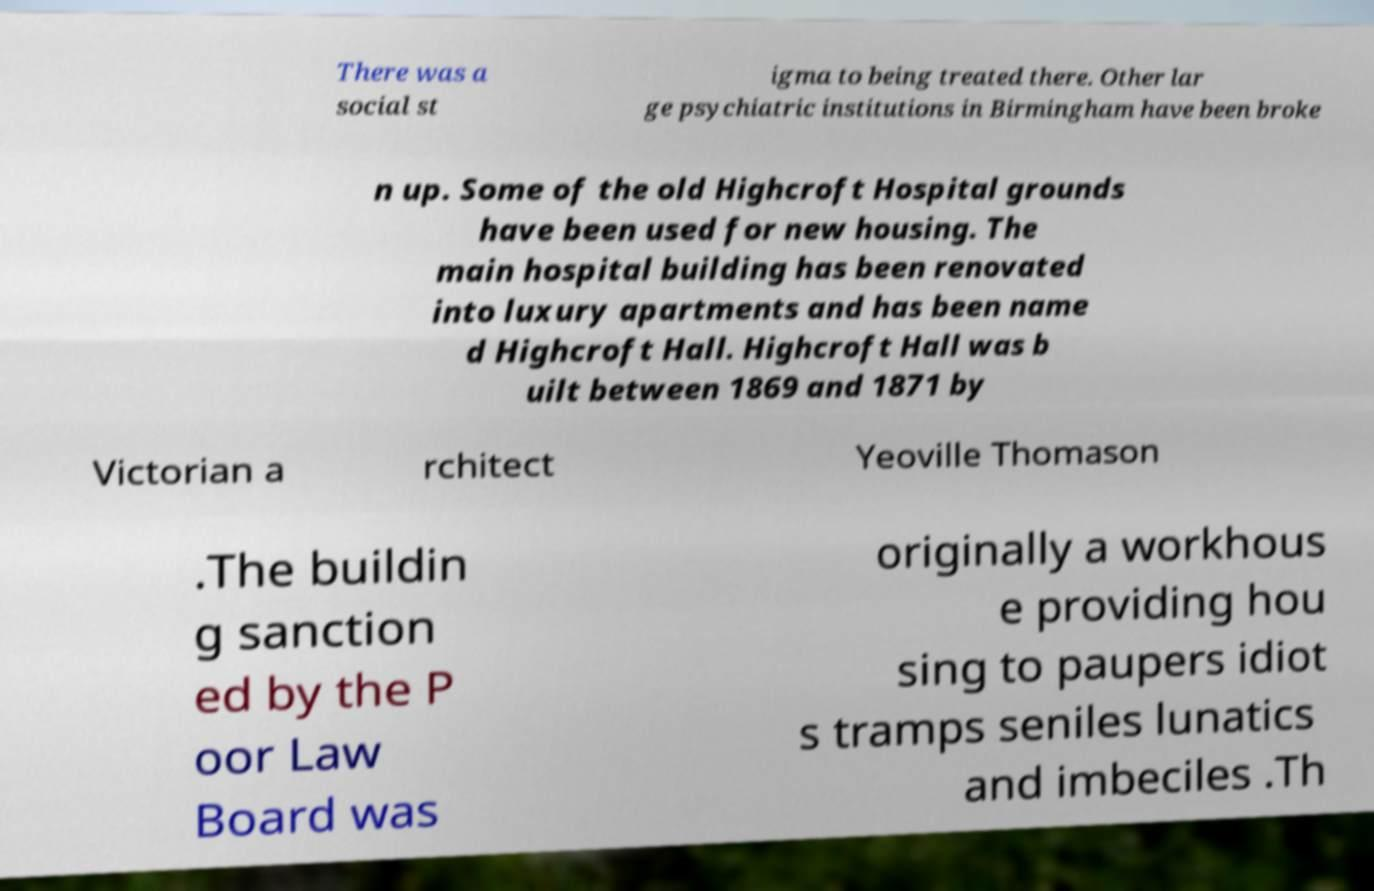There's text embedded in this image that I need extracted. Can you transcribe it verbatim? There was a social st igma to being treated there. Other lar ge psychiatric institutions in Birmingham have been broke n up. Some of the old Highcroft Hospital grounds have been used for new housing. The main hospital building has been renovated into luxury apartments and has been name d Highcroft Hall. Highcroft Hall was b uilt between 1869 and 1871 by Victorian a rchitect Yeoville Thomason .The buildin g sanction ed by the P oor Law Board was originally a workhous e providing hou sing to paupers idiot s tramps seniles lunatics and imbeciles .Th 